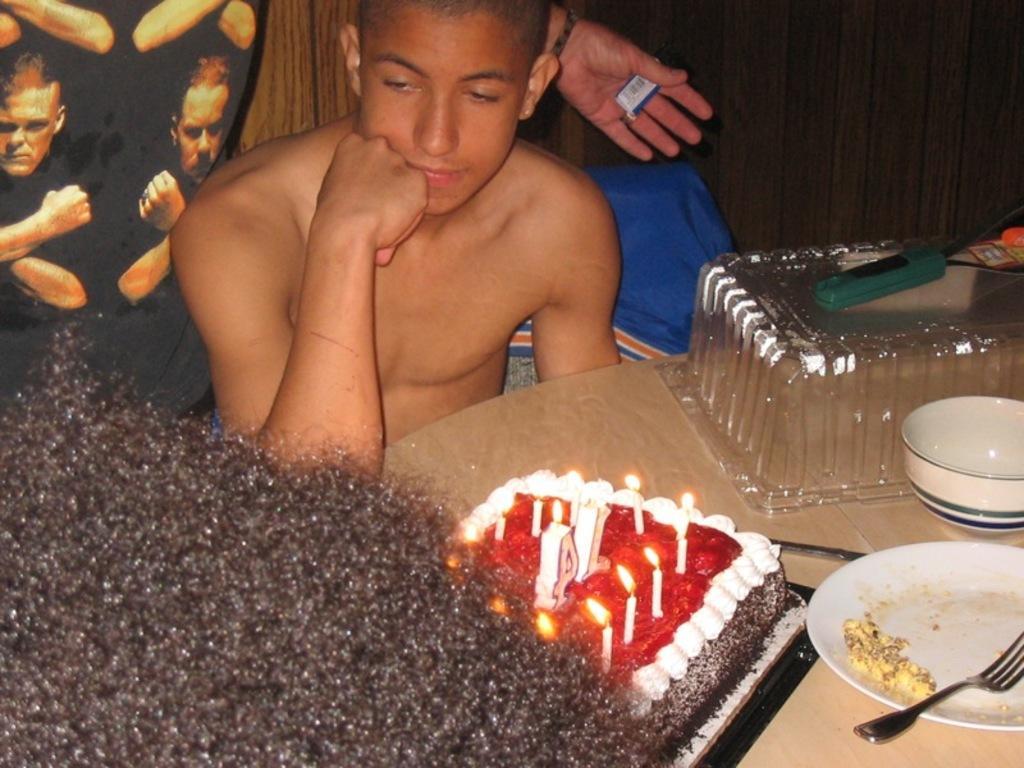Please provide a concise description of this image. In this image we can see a person sitting in a room and a person is standing and holding an object and there is a table in front of the person, on the table there is a cake with candles, plate with food item and a fork, a bowl and a plastic box, on the box there is an object and on the left side it looks like a person´s hair. 